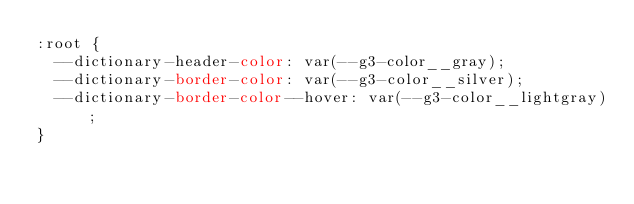Convert code to text. <code><loc_0><loc_0><loc_500><loc_500><_CSS_>:root {
  --dictionary-header-color: var(--g3-color__gray);
  --dictionary-border-color: var(--g3-color__silver);
  --dictionary-border-color--hover: var(--g3-color__lightgray);
}
</code> 